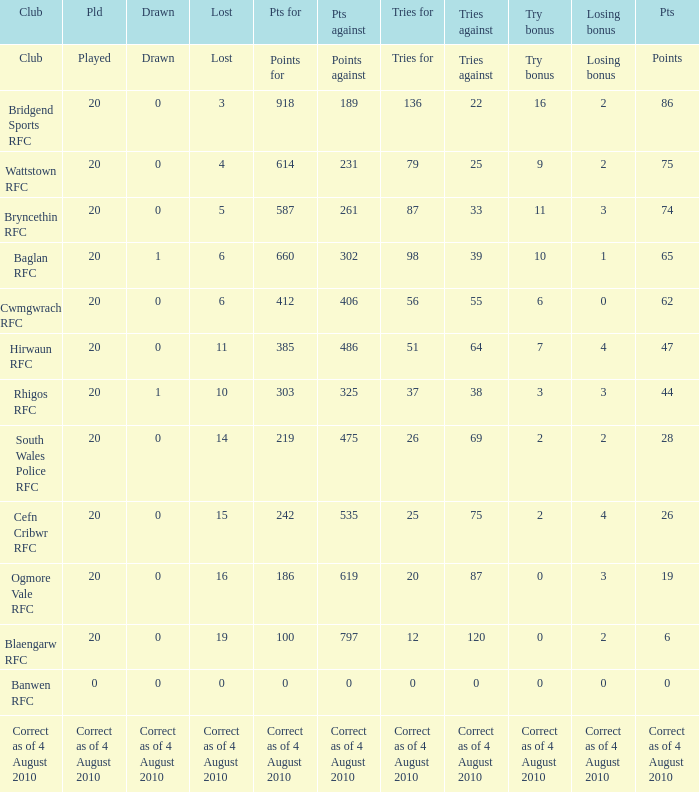What is the points against when drawn is drawn? Points against. 